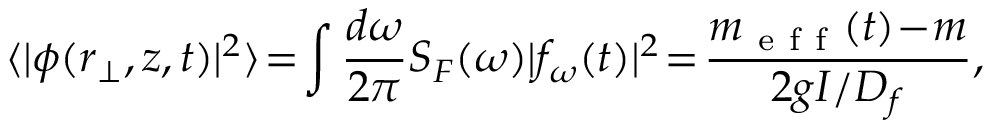Convert formula to latex. <formula><loc_0><loc_0><loc_500><loc_500>\langle | \phi ( { r } _ { \perp } , z , t ) | ^ { 2 } \rangle \, = \, \int \frac { d \omega } { 2 \pi } S _ { F } ( \omega ) | f _ { \omega } ( t ) | ^ { 2 } \, = \, \frac { m _ { e f f } ( t ) \, - \, m } { 2 g I / D _ { f } } ,</formula> 